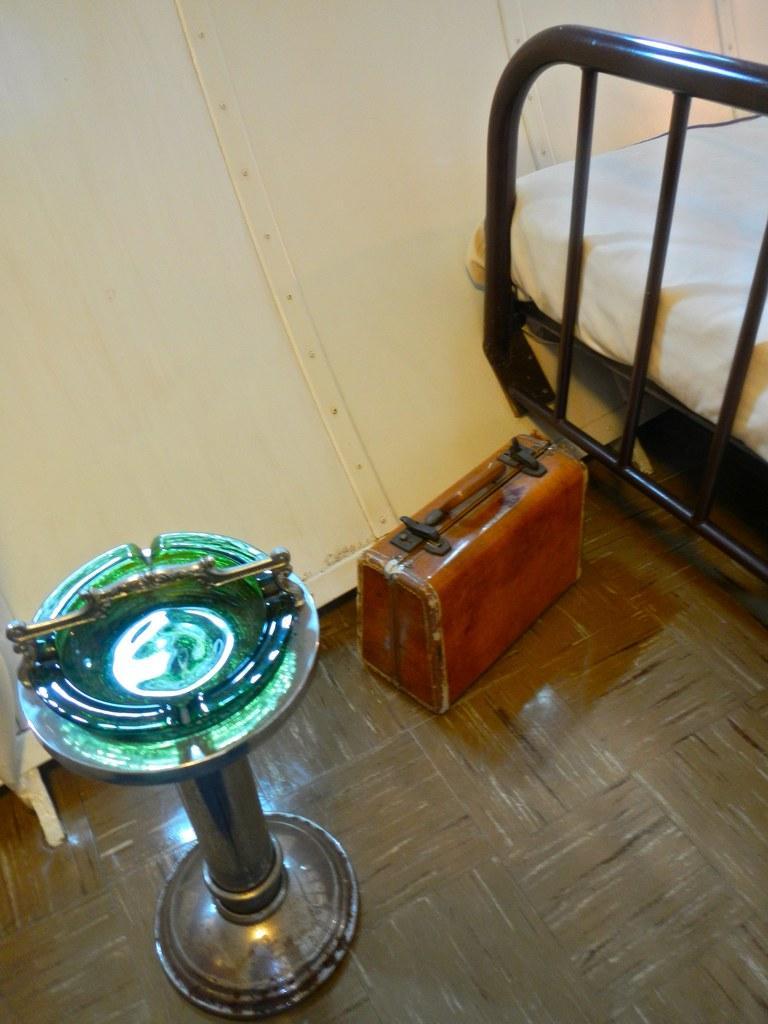What object can be seen on the floor in the image? There is a suitcase on the floor in the image. What type of structure is present in the image? There is a metal structured device in the image. What piece of furniture is visible in the image? There is a bed in the image. What type of pear is sitting on the bed in the image? There is no pear present in the image; the bed is empty. How much salt is visible on the metal structured device in the image? There is no salt present on the metal structured device in the image. 